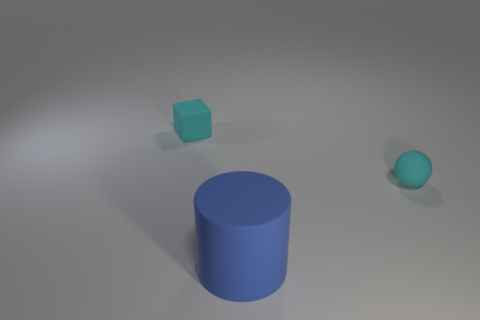Add 3 cyan rubber spheres. How many objects exist? 6 Subtract 1 cubes. How many cubes are left? 0 Subtract all green cylinders. How many green balls are left? 0 Add 1 cyan matte cubes. How many cyan matte cubes exist? 2 Subtract 0 gray blocks. How many objects are left? 3 Subtract all cylinders. How many objects are left? 2 Subtract all yellow cylinders. Subtract all green cubes. How many cylinders are left? 1 Subtract all big rubber objects. Subtract all tiny cyan objects. How many objects are left? 0 Add 2 small rubber cubes. How many small rubber cubes are left? 3 